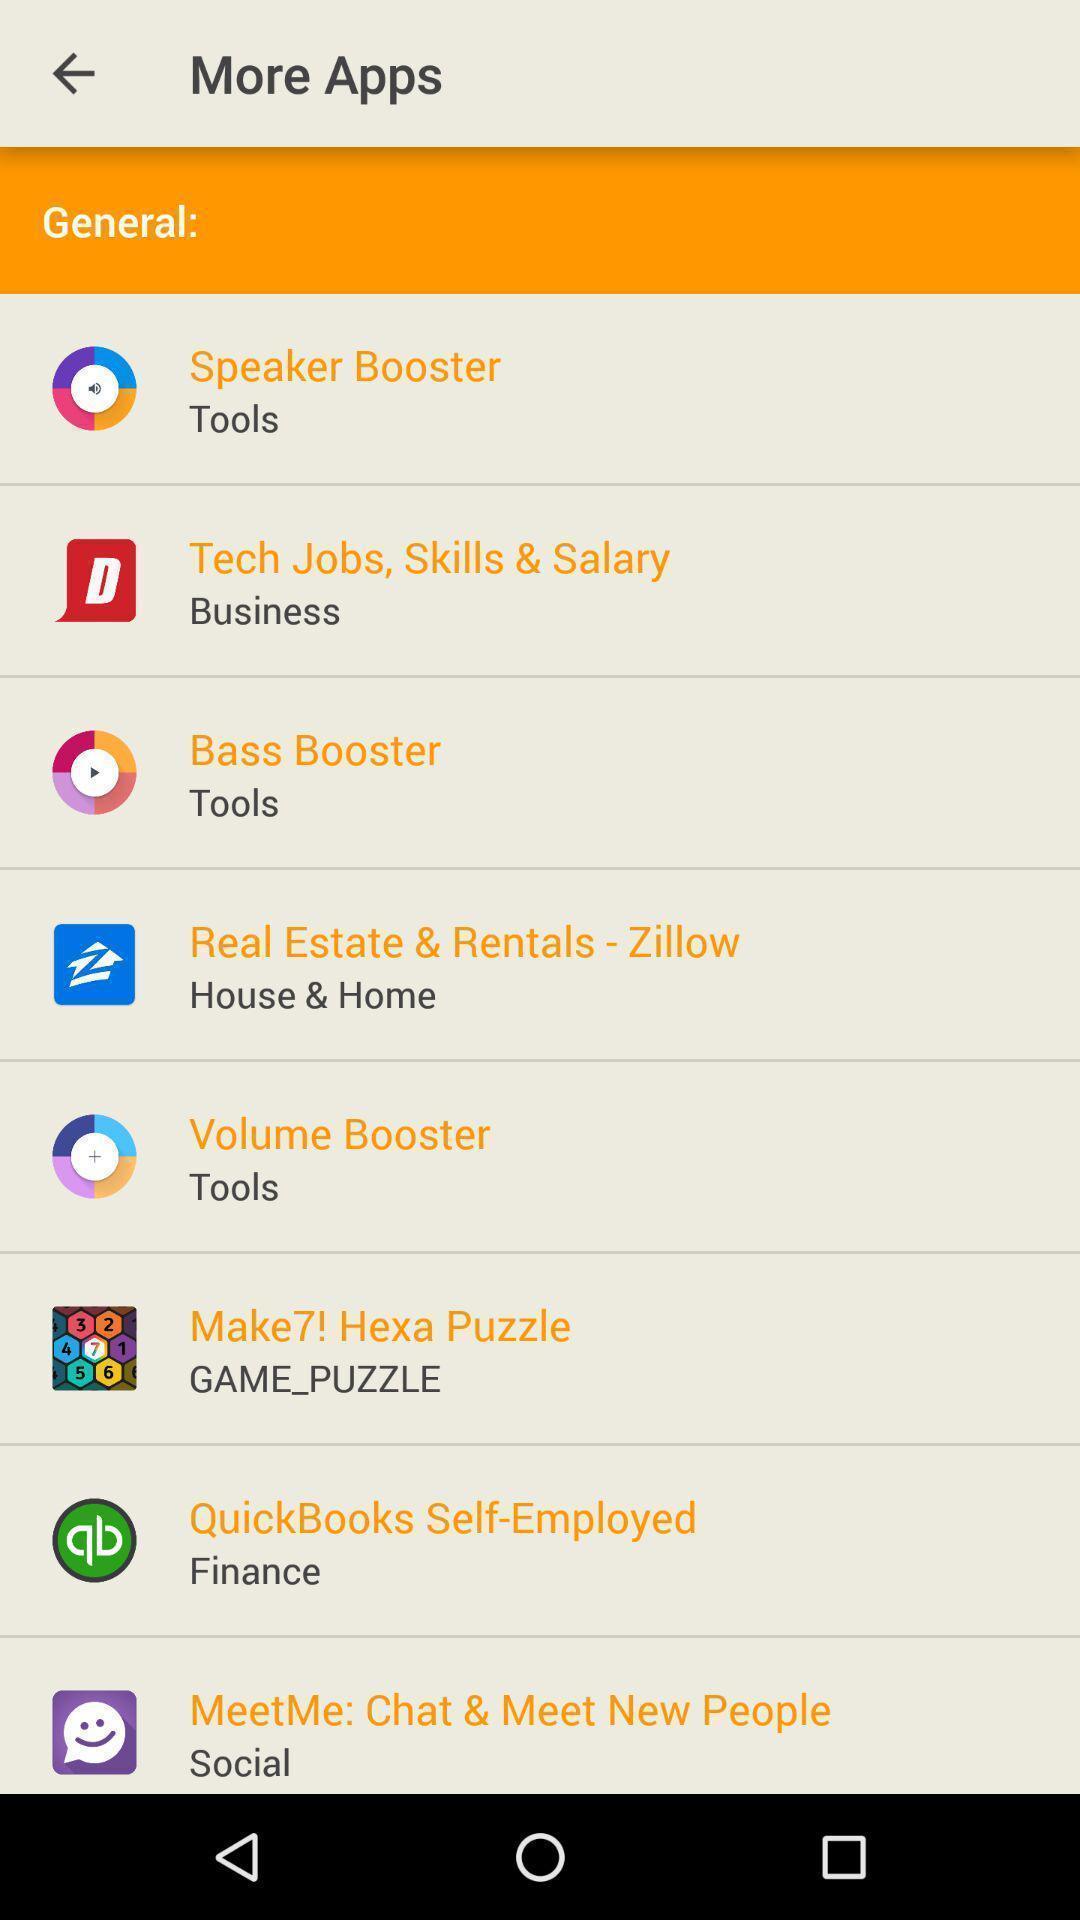Explain the elements present in this screenshot. Page displays different kind of applications. 